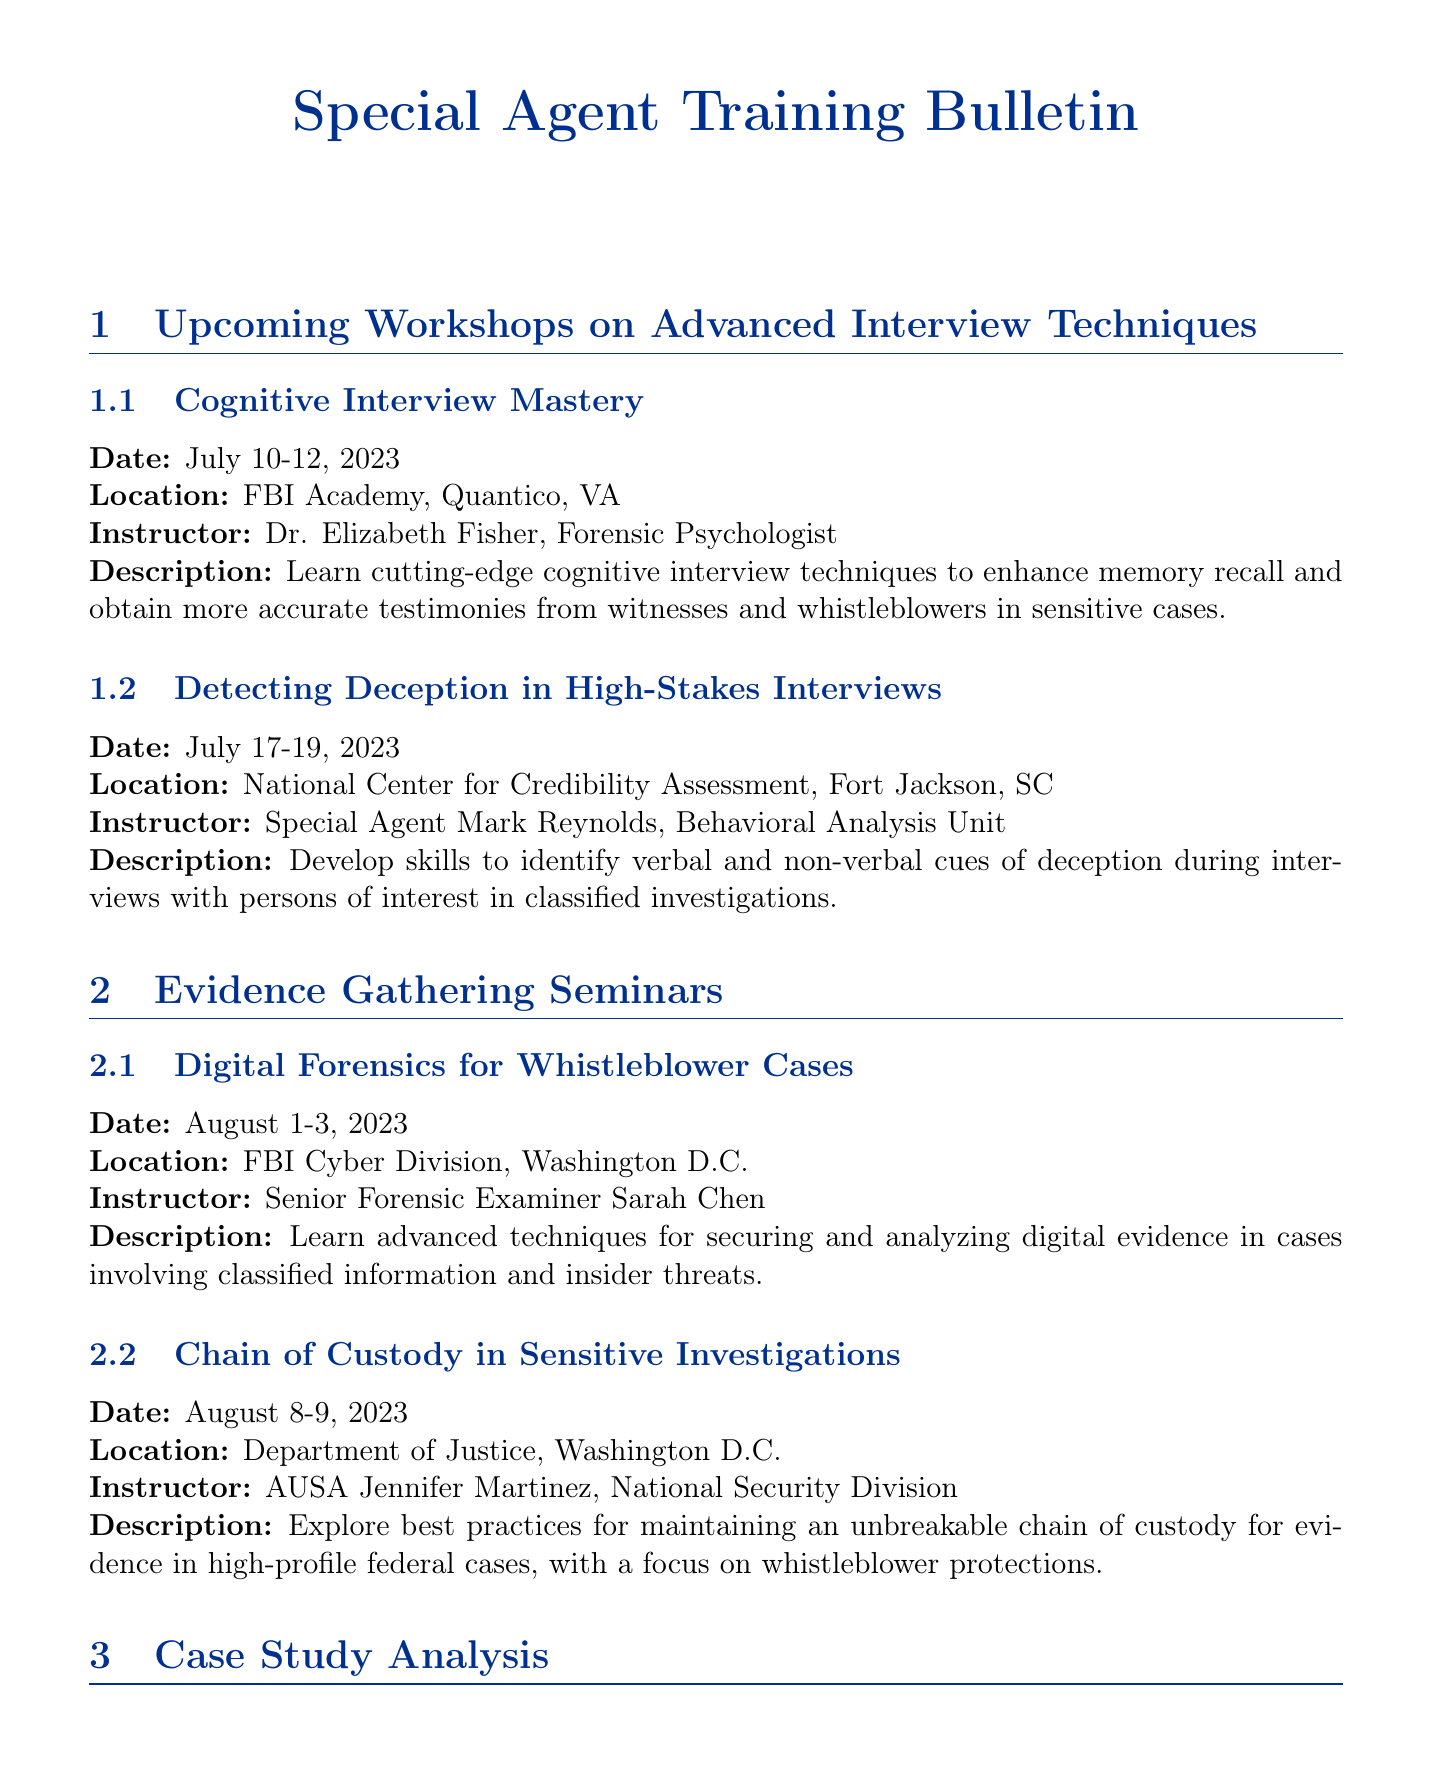What is the name of the workshop on cognitive interview techniques? The workshop on cognitive interview techniques is called "Cognitive Interview Mastery."
Answer: Cognitive Interview Mastery When is the seminar on digital forensics scheduled? The seminar on digital forensics is scheduled for August 1-3, 2023.
Answer: August 1-3, 2023 Who is the instructor for the workshop on detecting deception? The instructor for the workshop on detecting deception is Special Agent Mark Reynolds.
Answer: Special Agent Mark Reynolds What is the location of the seminar on chain of custody? The seminar on chain of custody is located at the Department of Justice, Washington D.C.
Answer: Department of Justice, Washington D.C What key topic is addressed in the recent changes to the Whistleblower Protection Act? The recent changes address new provisions for classified information disclosures.
Answer: New provisions for classified information disclosures Which case study is analyzed in the upcoming training? The analyzed case study is titled "The Snowden Affair: Lessons Learned."
Answer: The Snowden Affair: Lessons Learned Who is the presenter for the case study analysis? The presenter for the case study analysis is Former NSA Director Admiral Michael Rogers.
Answer: Former NSA Director Admiral Michael Rogers What is a resource mentioned for managing evidence? A resource mentioned for managing evidence is the Secure Evidence Management System (SEMS).
Answer: Secure Evidence Management System (SEMS) What date is the workshop on cognitive interview mastery ending? The workshop on cognitive interview mastery ends on July 12, 2023.
Answer: July 12, 2023 